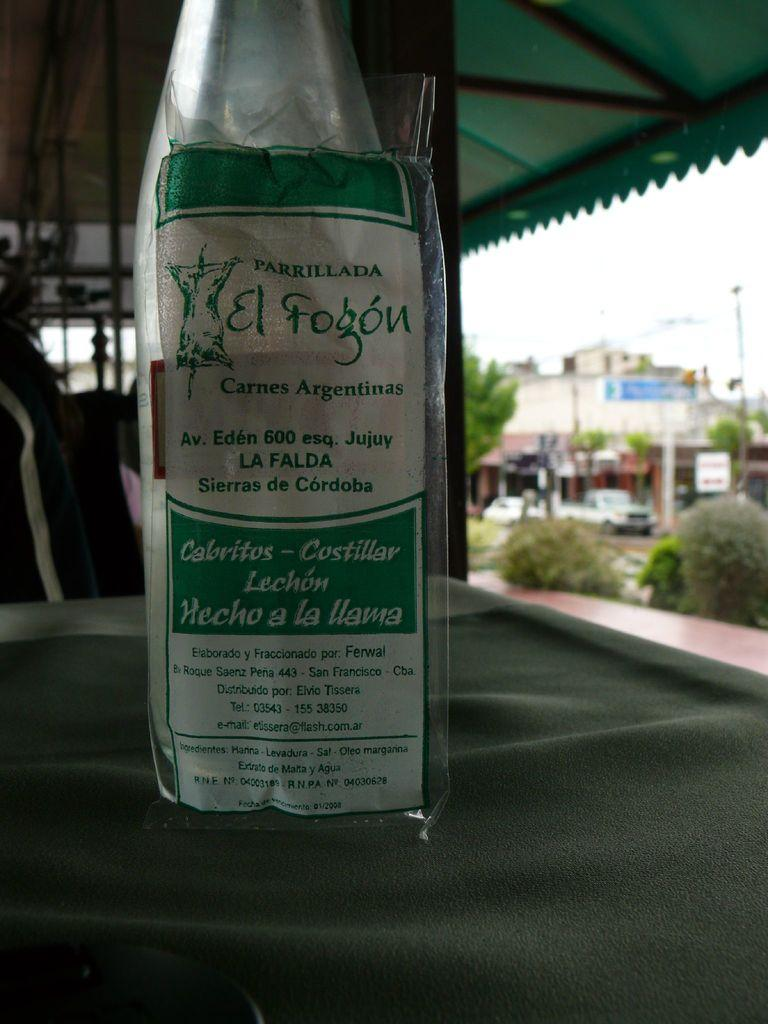<image>
Present a compact description of the photo's key features. A package that says carnes Argentinas on it sits on an outdoor table. 